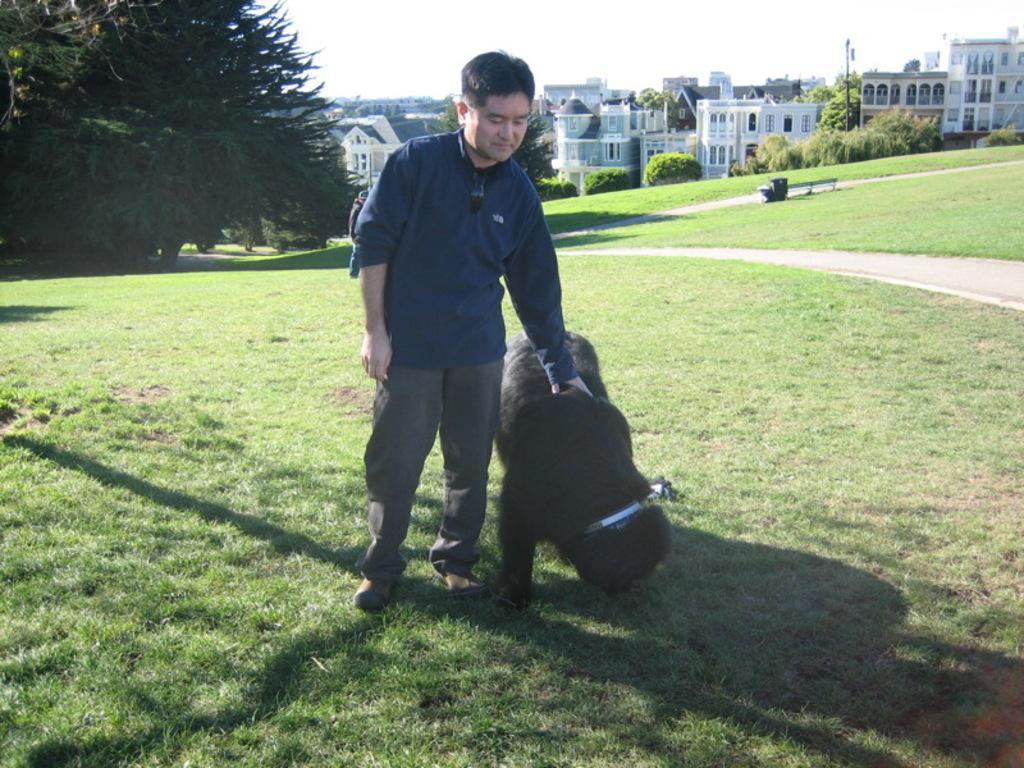Please provide a concise description of this image. In this picture the person is holding the animal both are standing on the grassy land behind the person some trees and buildings are there and the background is sunny. 